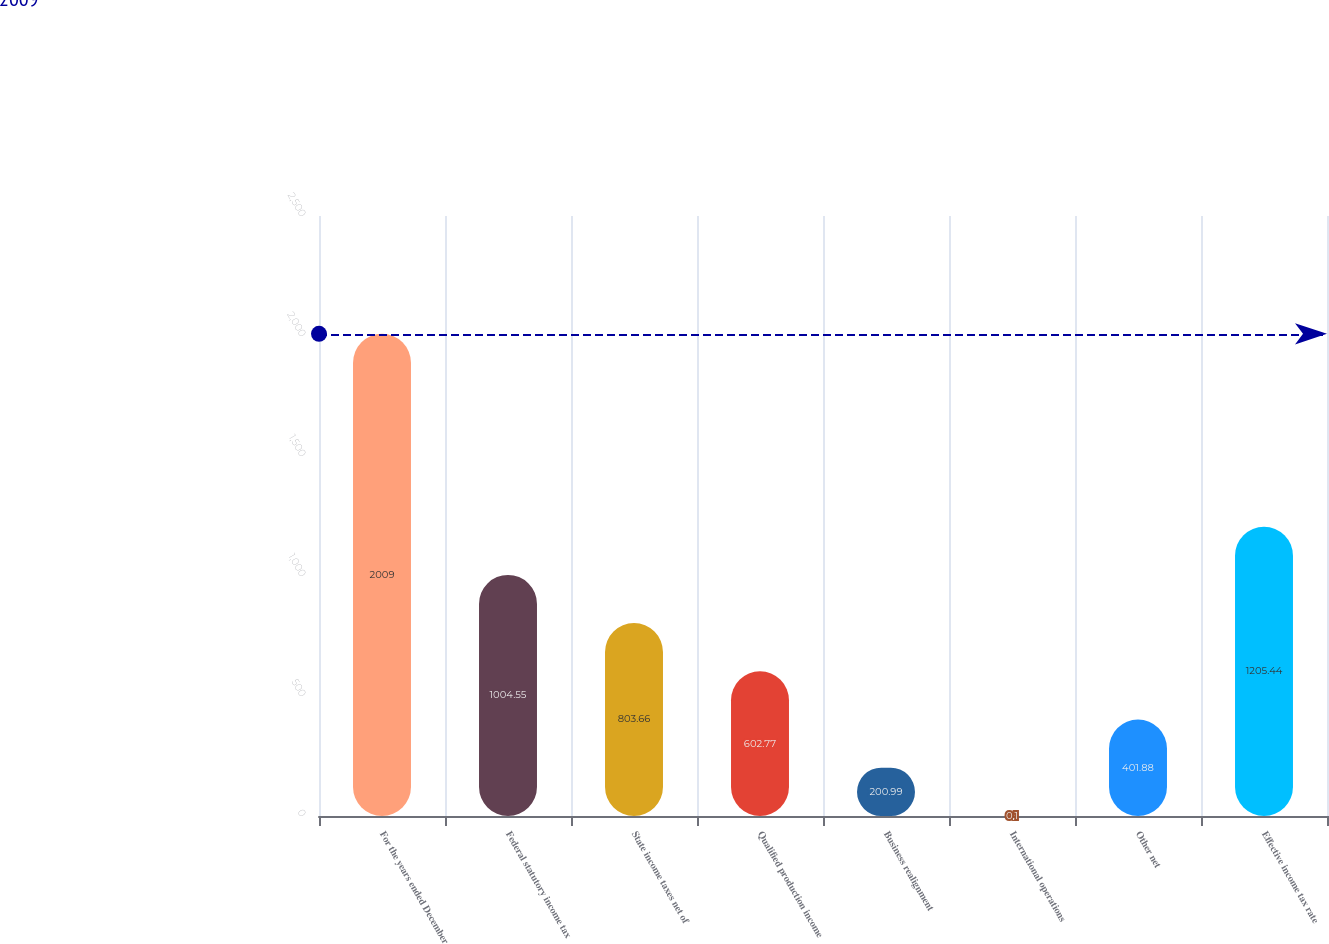Convert chart. <chart><loc_0><loc_0><loc_500><loc_500><bar_chart><fcel>For the years ended December<fcel>Federal statutory income tax<fcel>State income taxes net of<fcel>Qualified production income<fcel>Business realignment<fcel>International operations<fcel>Other net<fcel>Effective income tax rate<nl><fcel>2009<fcel>1004.55<fcel>803.66<fcel>602.77<fcel>200.99<fcel>0.1<fcel>401.88<fcel>1205.44<nl></chart> 